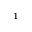<formula> <loc_0><loc_0><loc_500><loc_500>^ { 1 }</formula> 